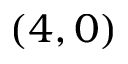Convert formula to latex. <formula><loc_0><loc_0><loc_500><loc_500>( 4 , 0 )</formula> 